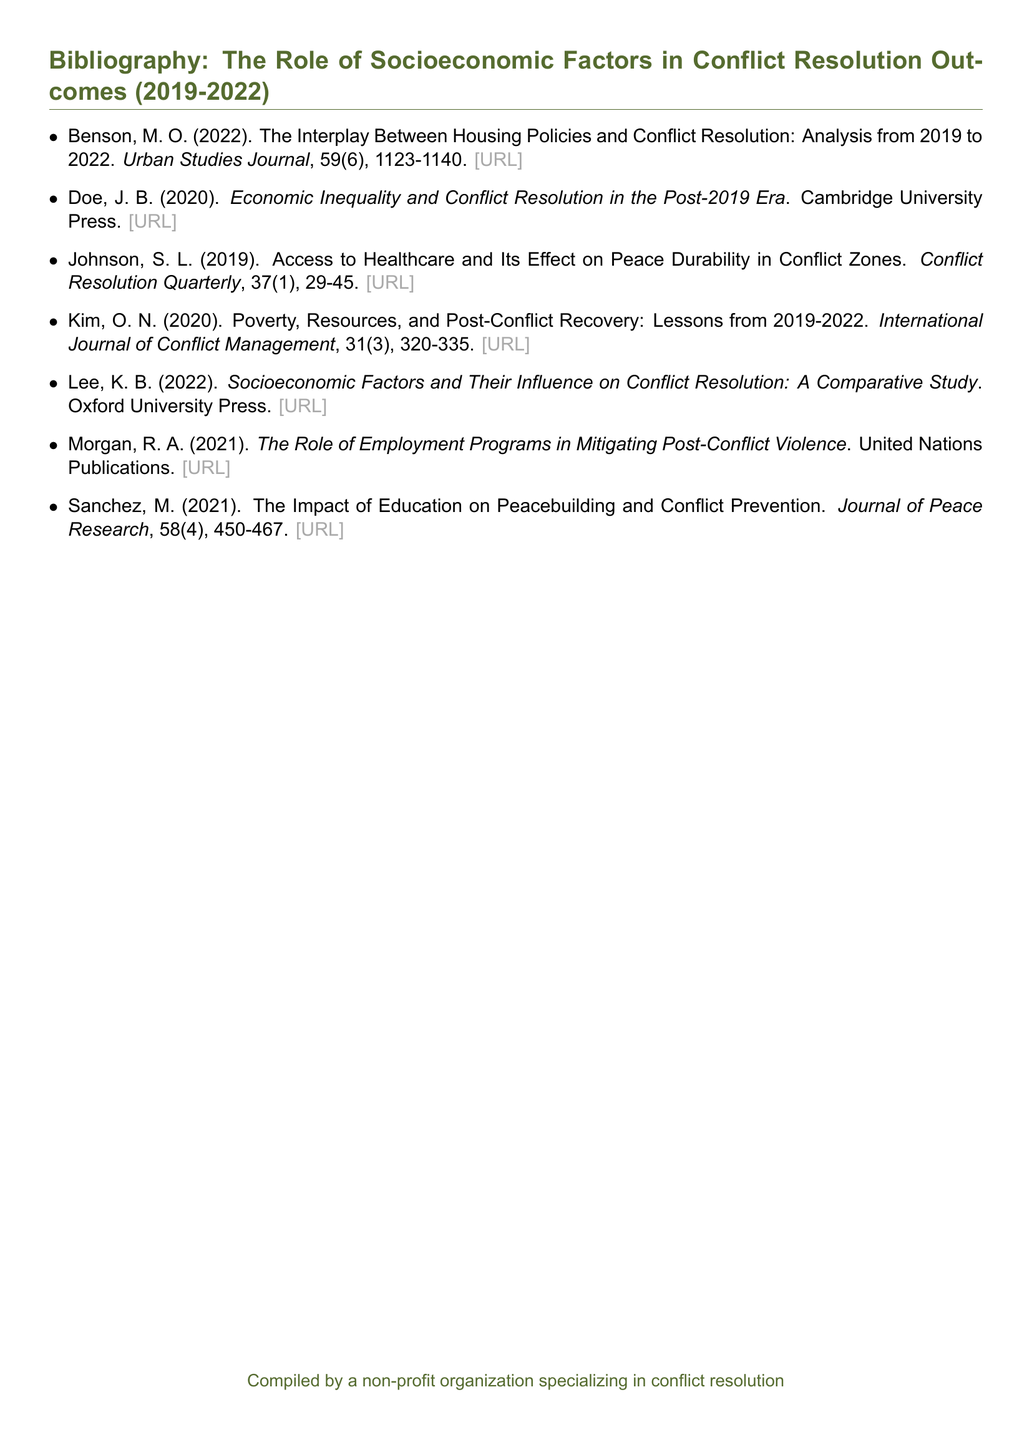What is the title of Benson's work? The title is listed as "The Interplay Between Housing Policies and Conflict Resolution: Analysis from 2019 to 2022."
Answer: The Interplay Between Housing Policies and Conflict Resolution: Analysis from 2019 to 2022 Who published "Economic Inequality and Conflict Resolution in the Post-2019 Era"? The work was published by Cambridge University Press.
Answer: Cambridge University Press In what year did Johnson publish their article? The year of publication for Johnson's work is indicated as 2019.
Answer: 2019 How many pages does Kim’s article span? Kim’s article is listed as having page numbers 320-335, indicating it spans 16 pages.
Answer: 16 pages What is the main subject of the article by Sanchez? The subject of Sanchez's article is the impact of education on peacebuilding and conflict prevention.
Answer: Education and peacebuilding Which publication features Morgan's work? Morgan's work is published by United Nations Publications.
Answer: United Nations Publications What is the volume number of the "Journal of Peace Research" containing Sanchez’s article? The volume number of Sanchez’s article is 58.
Answer: 58 What is the focus of Lee's comparative study? Lee's study focuses on socioeconomic factors and their influence on conflict resolution.
Answer: Socioeconomic factors and conflict resolution 